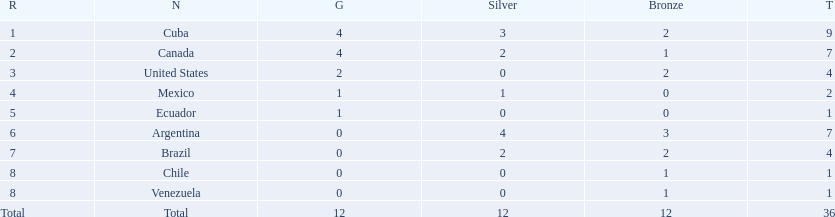What were all of the nations involved in the canoeing at the 2011 pan american games? Cuba, Canada, United States, Mexico, Ecuador, Argentina, Brazil, Chile, Venezuela, Total. Of these, which had a numbered rank? Cuba, Canada, United States, Mexico, Ecuador, Argentina, Brazil, Chile, Venezuela. From these, which had the highest number of bronze? Argentina. 